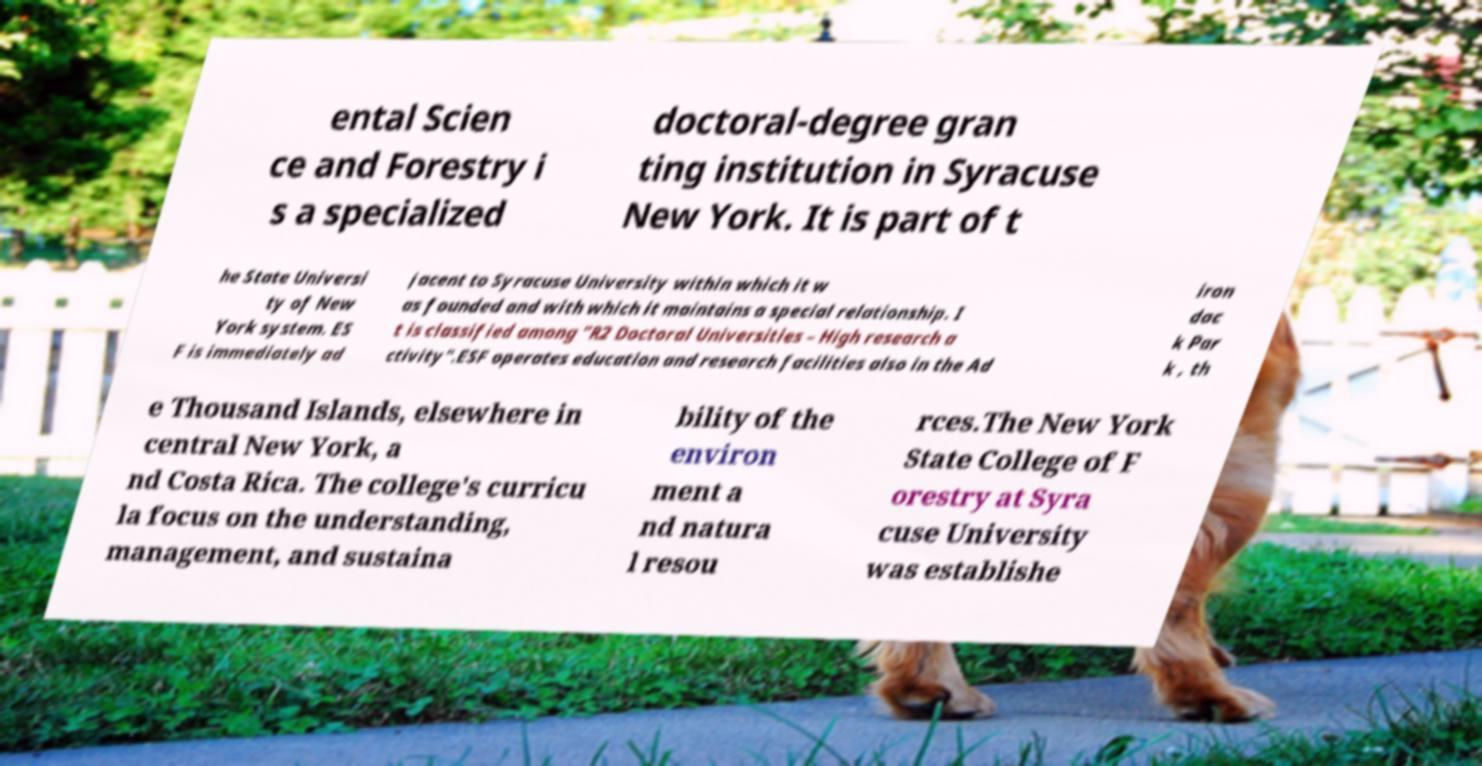Can you read and provide the text displayed in the image?This photo seems to have some interesting text. Can you extract and type it out for me? ental Scien ce and Forestry i s a specialized doctoral-degree gran ting institution in Syracuse New York. It is part of t he State Universi ty of New York system. ES F is immediately ad jacent to Syracuse University within which it w as founded and with which it maintains a special relationship. I t is classified among "R2 Doctoral Universities – High research a ctivity".ESF operates education and research facilities also in the Ad iron dac k Par k , th e Thousand Islands, elsewhere in central New York, a nd Costa Rica. The college's curricu la focus on the understanding, management, and sustaina bility of the environ ment a nd natura l resou rces.The New York State College of F orestry at Syra cuse University was establishe 